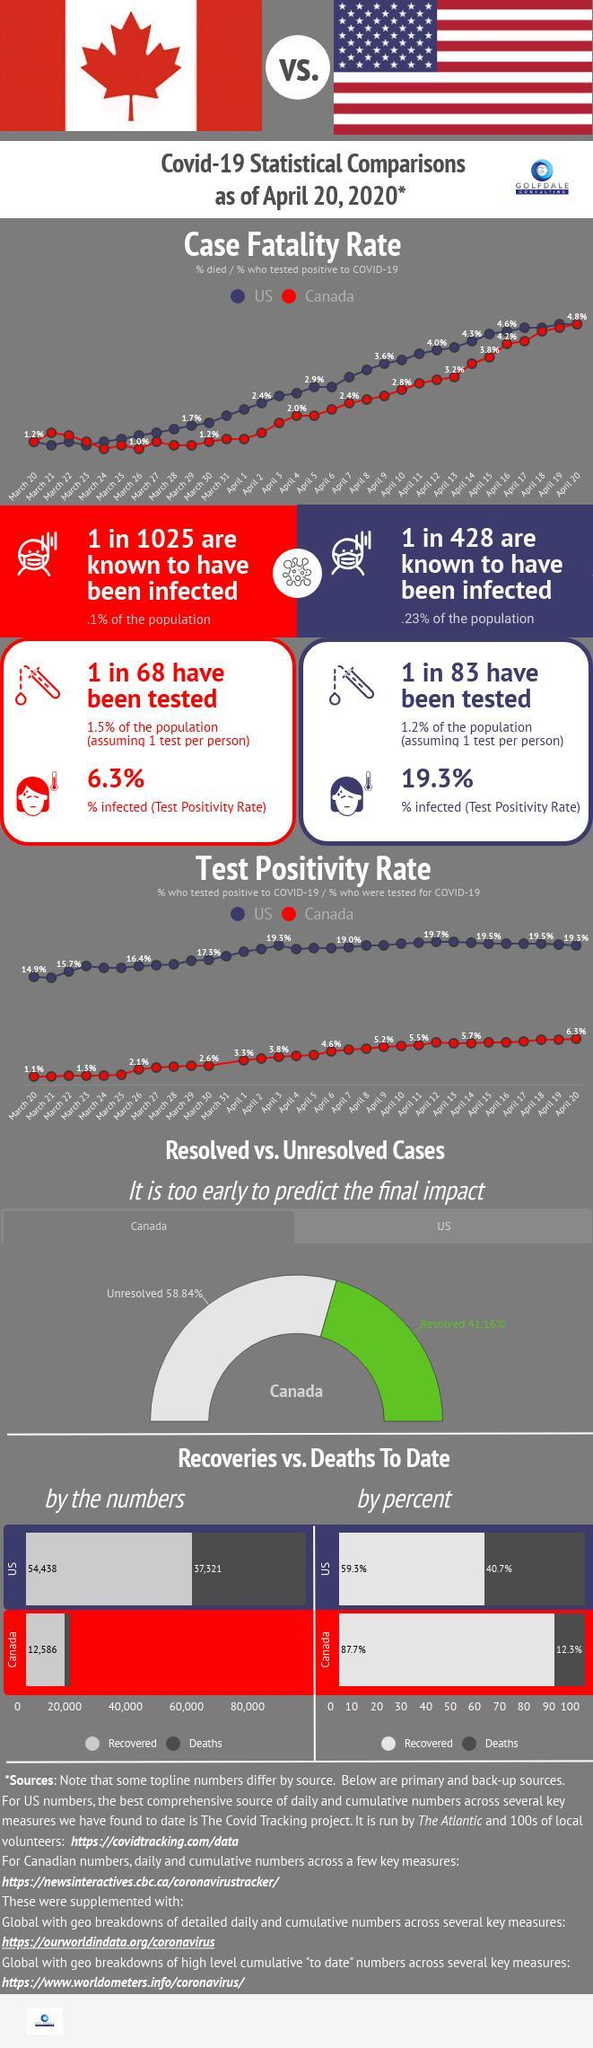What is the case fatality rate due to Covid-19 in the US on April 16, 2020?
Answer the question with a short phrase. 4.6% What is the test positivity rate in Canada as of April 20, 2020? 6.3% What percentage of COVID-19 deaths were reported in Canada as of April 20, 2020? 12.3% What is the test positivity rate in the US as of April 20, 2020? 19.3% What is the case fatality rate due to Covid-19 in Canada on March 26, 2020? 1.0% What is the number of COVID-19 deaths reported in the US as of April 20, 2020? 37,321 How many recovered cases of COVID-19 were reported in the US as of April 20, 2020? 54,438 What percentage of recovered Covid-19 cases were reported in Canada as of April 20, 2020? 87.7% 